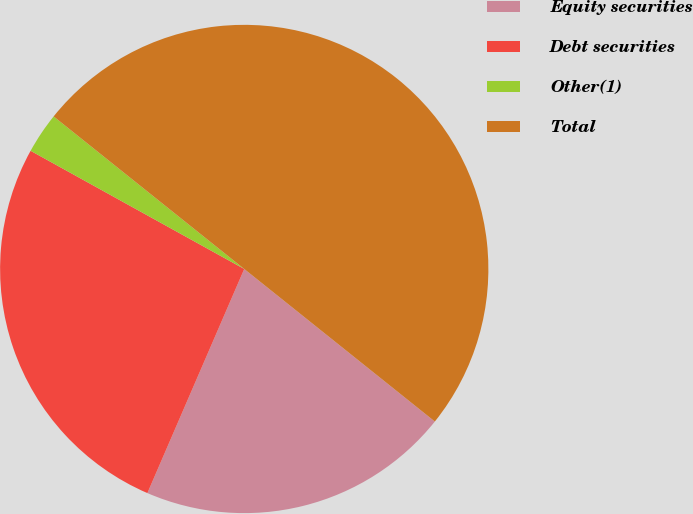Convert chart to OTSL. <chart><loc_0><loc_0><loc_500><loc_500><pie_chart><fcel>Equity securities<fcel>Debt securities<fcel>Other(1)<fcel>Total<nl><fcel>20.75%<fcel>26.55%<fcel>2.7%<fcel>50.0%<nl></chart> 